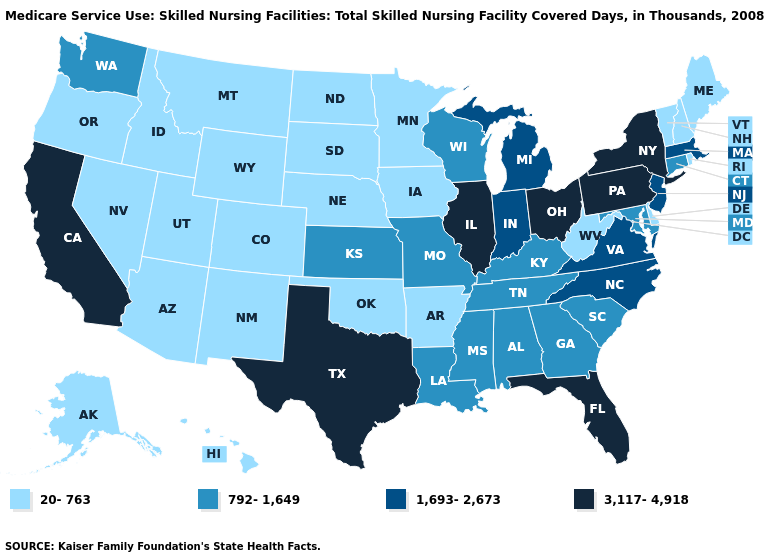Which states have the lowest value in the USA?
Give a very brief answer. Alaska, Arizona, Arkansas, Colorado, Delaware, Hawaii, Idaho, Iowa, Maine, Minnesota, Montana, Nebraska, Nevada, New Hampshire, New Mexico, North Dakota, Oklahoma, Oregon, Rhode Island, South Dakota, Utah, Vermont, West Virginia, Wyoming. How many symbols are there in the legend?
Concise answer only. 4. Name the states that have a value in the range 1,693-2,673?
Be succinct. Indiana, Massachusetts, Michigan, New Jersey, North Carolina, Virginia. What is the lowest value in the USA?
Quick response, please. 20-763. What is the highest value in the West ?
Give a very brief answer. 3,117-4,918. Does North Carolina have a lower value than Illinois?
Quick response, please. Yes. Does South Carolina have a lower value than Pennsylvania?
Be succinct. Yes. Which states have the lowest value in the USA?
Answer briefly. Alaska, Arizona, Arkansas, Colorado, Delaware, Hawaii, Idaho, Iowa, Maine, Minnesota, Montana, Nebraska, Nevada, New Hampshire, New Mexico, North Dakota, Oklahoma, Oregon, Rhode Island, South Dakota, Utah, Vermont, West Virginia, Wyoming. Does the map have missing data?
Keep it brief. No. Among the states that border Montana , which have the highest value?
Concise answer only. Idaho, North Dakota, South Dakota, Wyoming. How many symbols are there in the legend?
Concise answer only. 4. Name the states that have a value in the range 792-1,649?
Short answer required. Alabama, Connecticut, Georgia, Kansas, Kentucky, Louisiana, Maryland, Mississippi, Missouri, South Carolina, Tennessee, Washington, Wisconsin. Does the first symbol in the legend represent the smallest category?
Be succinct. Yes. What is the highest value in states that border North Carolina?
Short answer required. 1,693-2,673. Which states have the lowest value in the Northeast?
Write a very short answer. Maine, New Hampshire, Rhode Island, Vermont. 